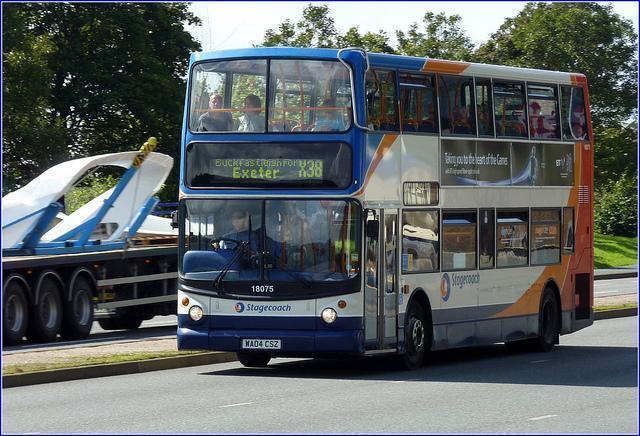In which country does this bus travel?
Choose the correct response, then elucidate: 'Answer: answer
Rationale: rationale.'
Options: Usa, chile, england, canada. Answer: england.
Rationale: The country is england. 